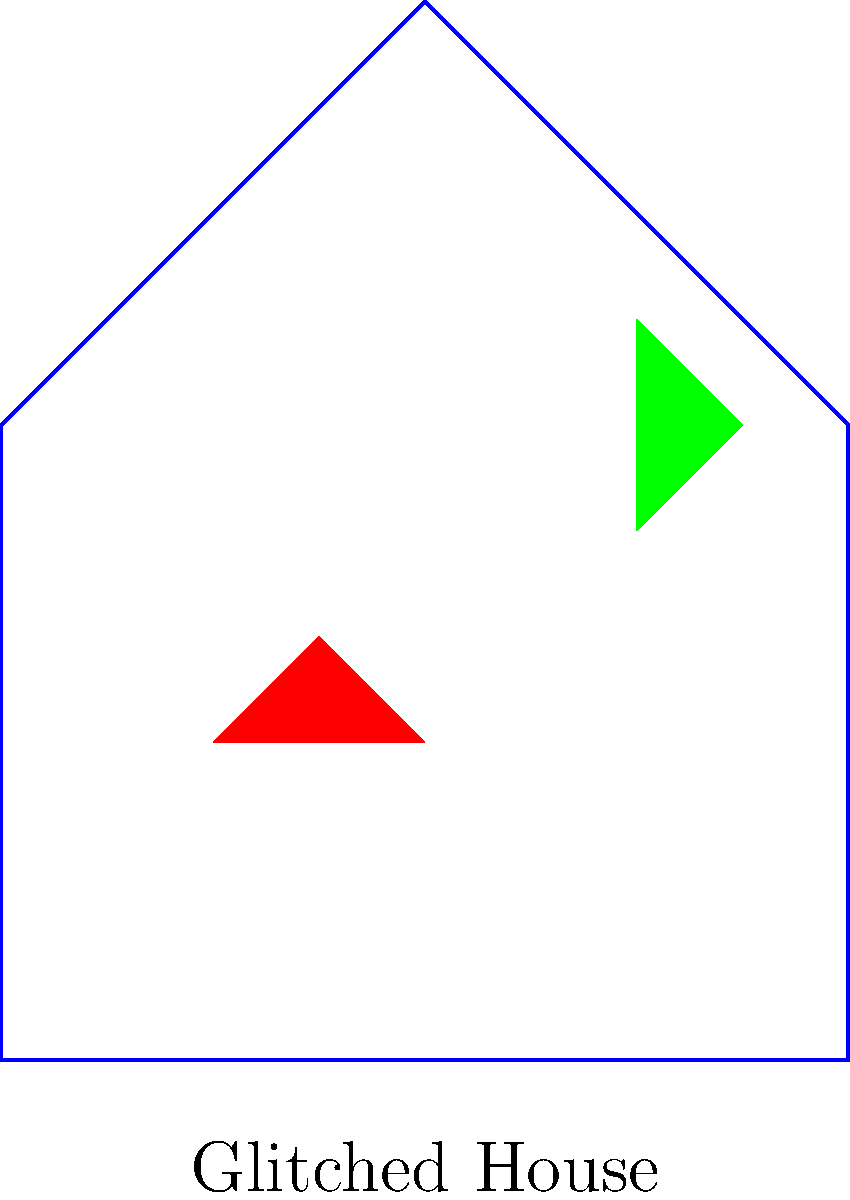In the context of algorithmic art and human perception, how might the presence of digital glitch effects, as shown in the image, impact the cognitive processes involved in object recognition? Consider the potential implications for both bottom-up and top-down processing. To answer this question, we need to consider several factors:

1. Bottom-up processing:
   - The glitch effects introduce unexpected colors and shapes that don't belong to the original object (house).
   - These anomalies may disrupt the initial feature detection stage of object recognition.
   - The visual system may struggle to integrate these unexpected elements into a coherent whole.

2. Top-down processing:
   - Prior knowledge of what a house typically looks like may help in recognizing the overall shape despite the glitches.
   - However, the glitches may create conflict between the expected representation and the actual visual input.

3. Attention and perceptual load:
   - The glitches may draw attention away from the main features of the house, potentially increasing cognitive load.
   - This could lead to slower recognition times or increased error rates in object identification tasks.

4. Perceptual adaptation:
   - With repeated exposure to glitch art, viewers might develop new perceptual strategies to cope with these distortions.
   - This could lead to faster recognition of glitched objects over time.

5. Aesthetic processing:
   - The unusual visual elements introduced by glitches might engage additional cognitive processes related to aesthetic appreciation or novelty detection.

6. Semantic interpretation:
   - The presence of glitches might affect the semantic associations triggered by the image, potentially leading to alternative interpretations of the object's identity or meaning.

Given these considerations, the digital glitch effects are likely to:
- Initially impair object recognition by disrupting normal feature integration processes.
- Increase cognitive load and processing time as the brain attempts to reconcile the unexpected visual elements with prior knowledge.
- Potentially enhance engagement with the image due to its novel and unusual appearance.
- Over time, possibly lead to the development of new perceptual strategies for processing glitched images.
Answer: Glitches disrupt feature integration, increase cognitive load, and may impair initial object recognition while potentially enhancing engagement and leading to new perceptual strategies over time. 